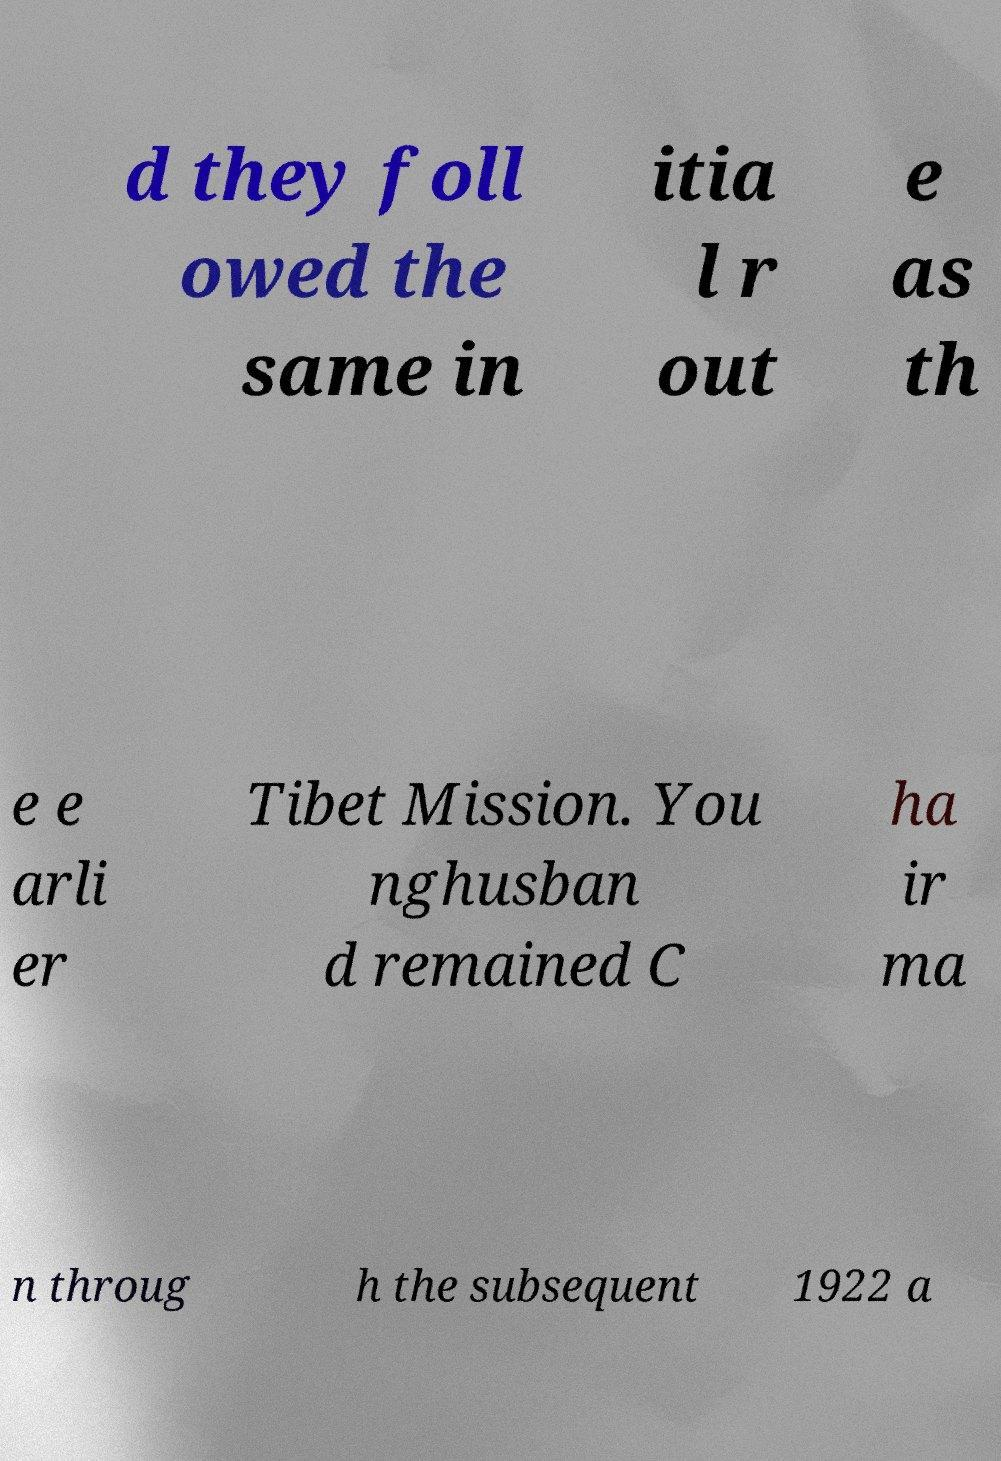Could you extract and type out the text from this image? d they foll owed the same in itia l r out e as th e e arli er Tibet Mission. You nghusban d remained C ha ir ma n throug h the subsequent 1922 a 